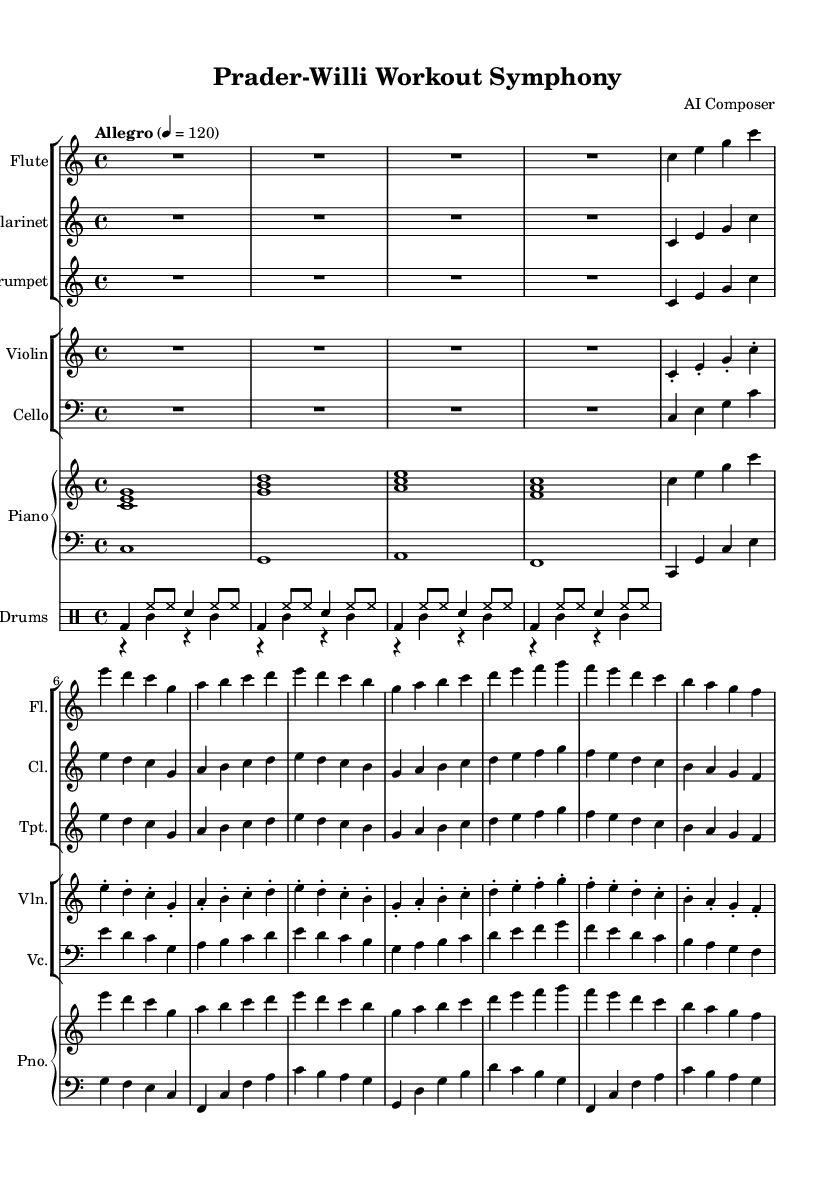What is the key signature of this music? The key signature is C major, which has no sharps or flats.
Answer: C major What is the time signature of this music? The time signature is indicated by the 4/4 marking at the beginning, which means there are four beats in each measure.
Answer: 4/4 What is the tempo marking for this piece? The tempo marking states "Allegro" with a metronome marking of 120, indicating a fast, lively pace.
Answer: Allegro 4 = 120 How many instruments are there in this symphony? The score includes six distinct instrumental parts: flute, clarinet, trumpet, violin, cello, piano, and drums. By counting each distinct part, we find a total of six different instruments.
Answer: Six What is the rhythmic pattern used in the drums section? The drums section has a repeating pattern that alternates between bass drum, hi-hats, and snare, creating a consistent and energetic rhythmic drive throughout the piece.
Answer: Bass and snare pattern Which section of this symphony features the melodic line predominantly? The woodwind section (flute, clarinet, trumpet) primarily carries the melodic line, while the strings and piano provide harmonic support.
Answer: Woodwind section In which section does the dynamics seem to vary more? The dynamics tend to vary more in the piano section as it combines both right hand and left-hand parts, which often contrasts in volume and intensity, enhancing the overall expression of the piece.
Answer: Piano section 